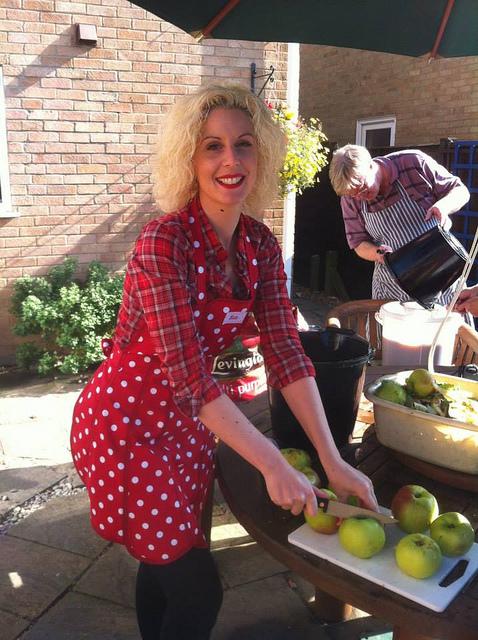How many apples?
Quick response, please. 5. What is the lady slicing?
Write a very short answer. Apples. What design is on the ladies apron?
Keep it brief. Polka dots. 